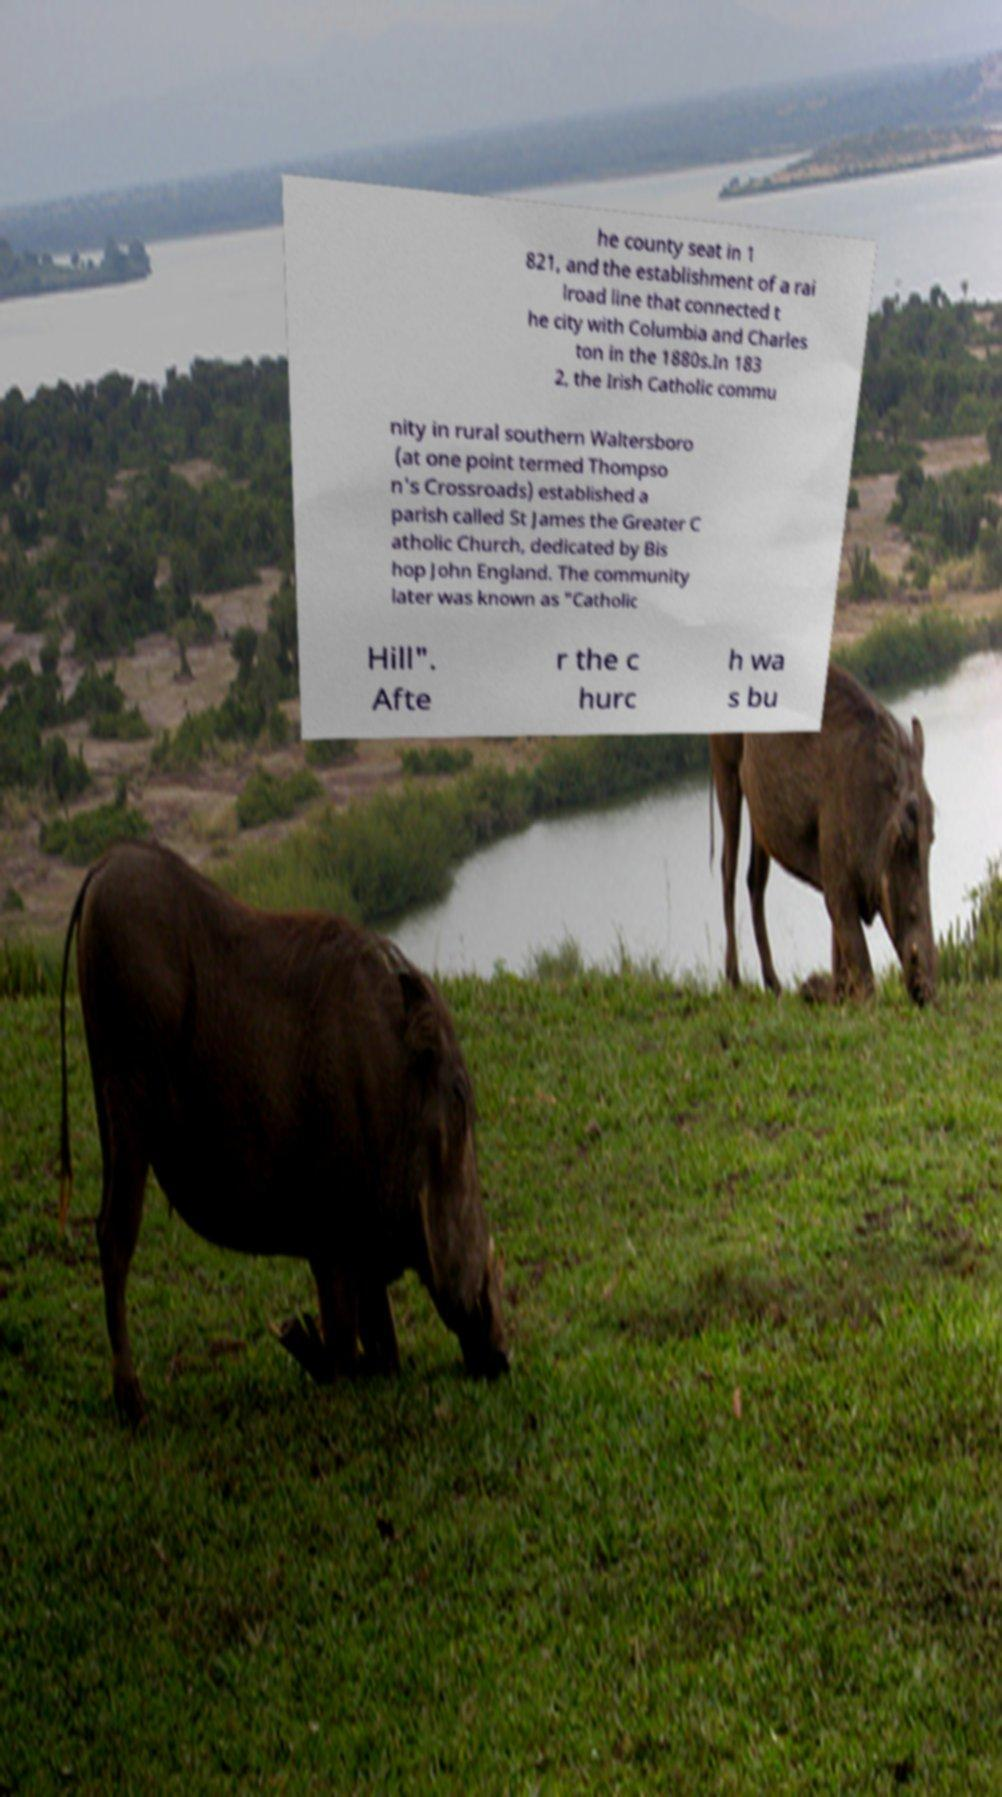Please identify and transcribe the text found in this image. he county seat in 1 821, and the establishment of a rai lroad line that connected t he city with Columbia and Charles ton in the 1880s.In 183 2, the Irish Catholic commu nity in rural southern Waltersboro (at one point termed Thompso n's Crossroads) established a parish called St James the Greater C atholic Church, dedicated by Bis hop John England. The community later was known as "Catholic Hill". Afte r the c hurc h wa s bu 